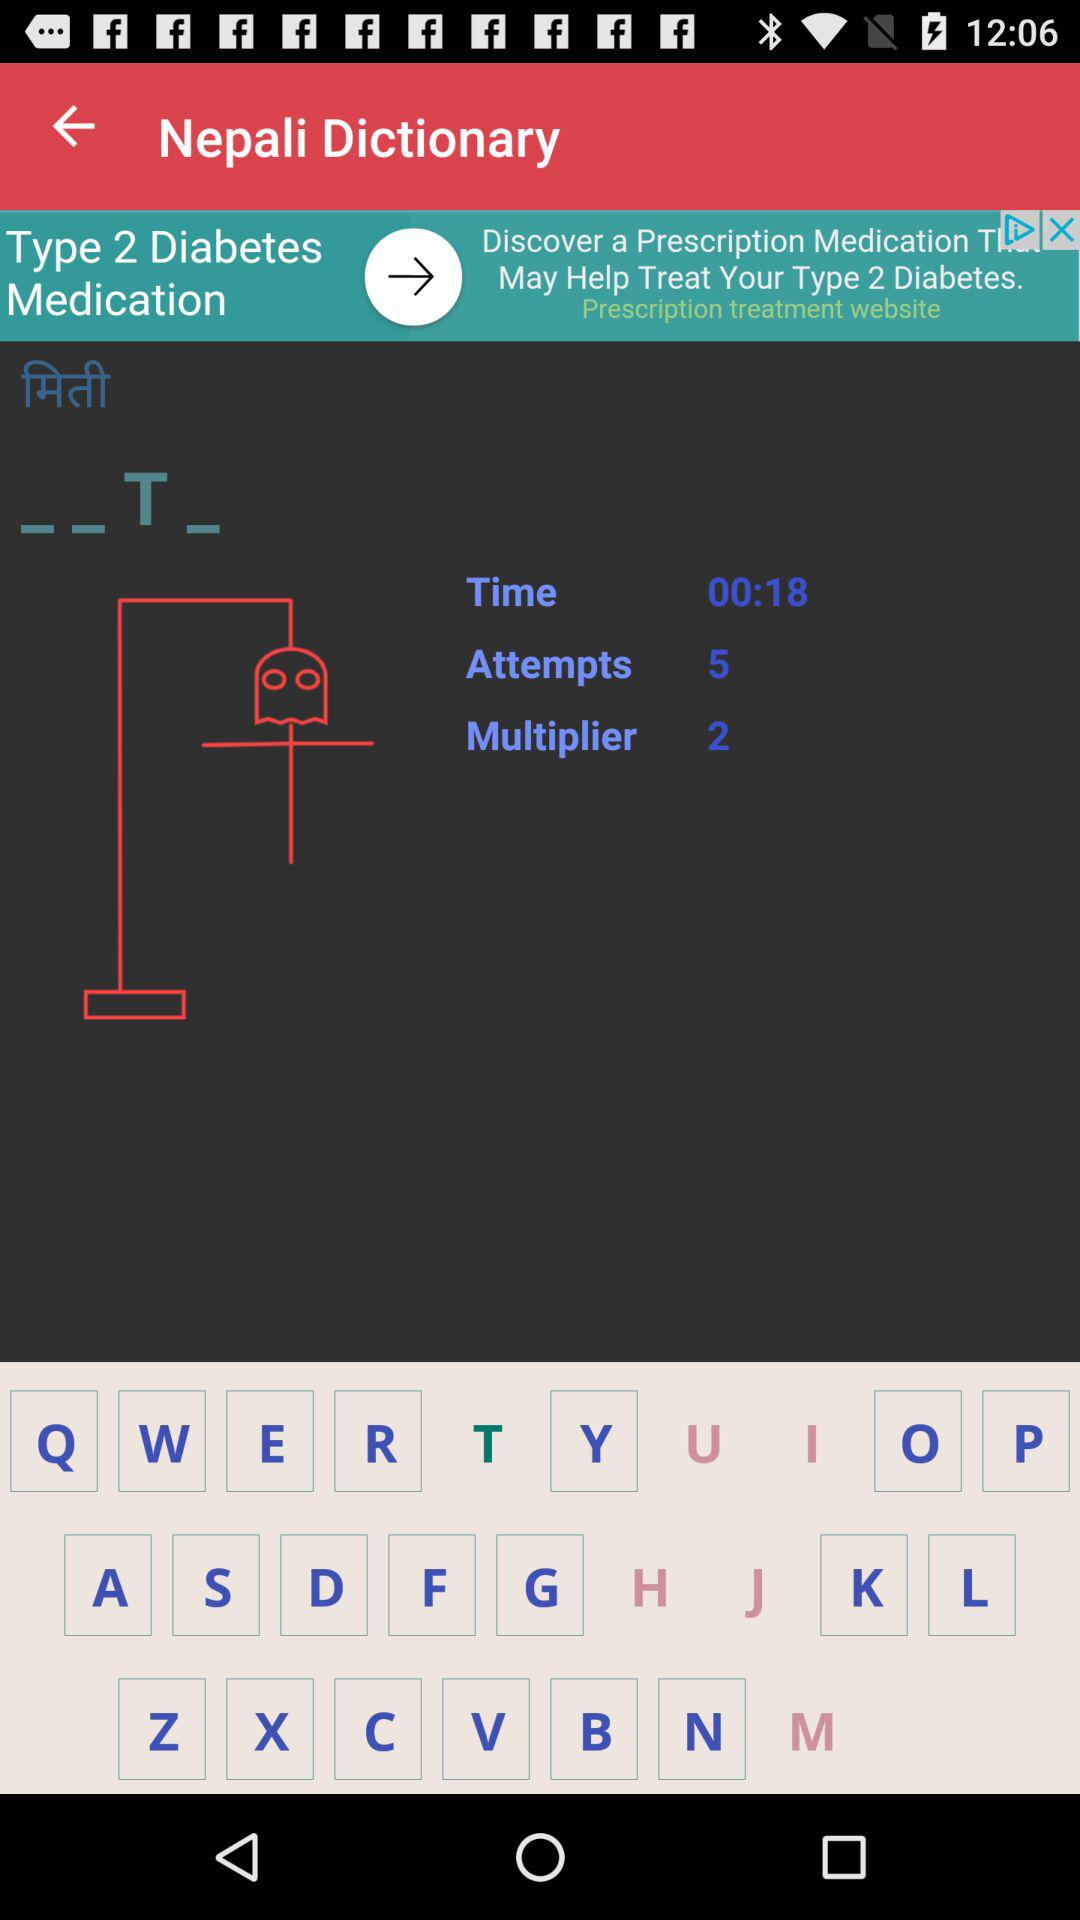How many attempts are there?
Answer the question using a single word or phrase. 5 